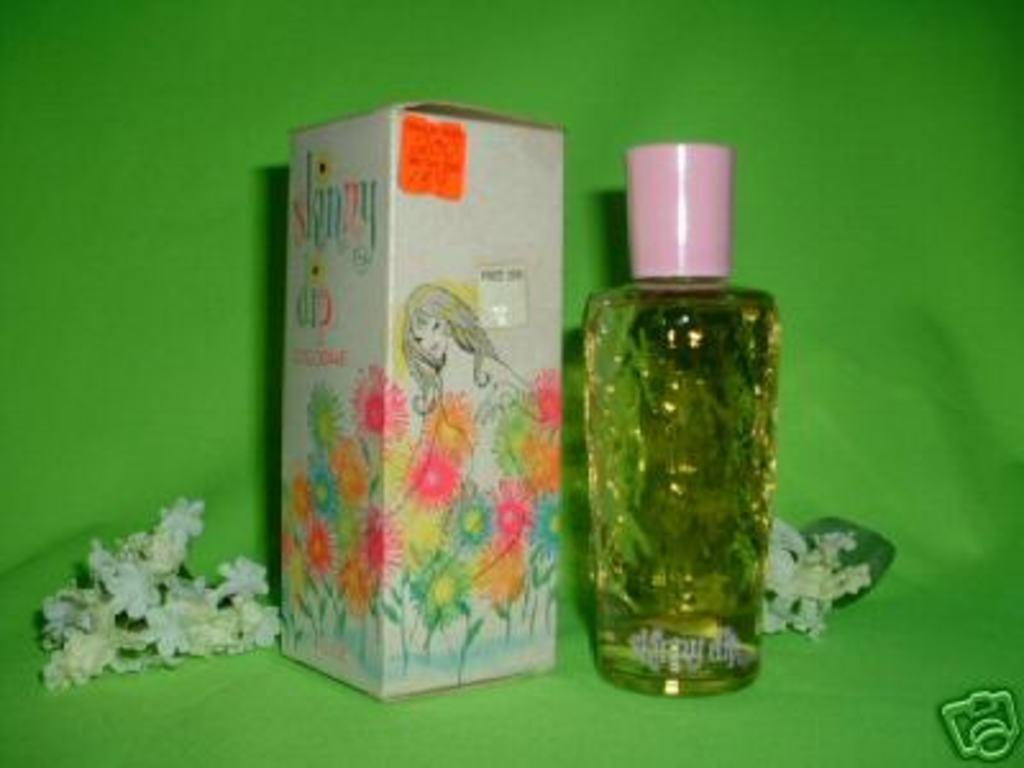<image>
Provide a brief description of the given image. A bottle of liquid and a box that says skinny on the side. 